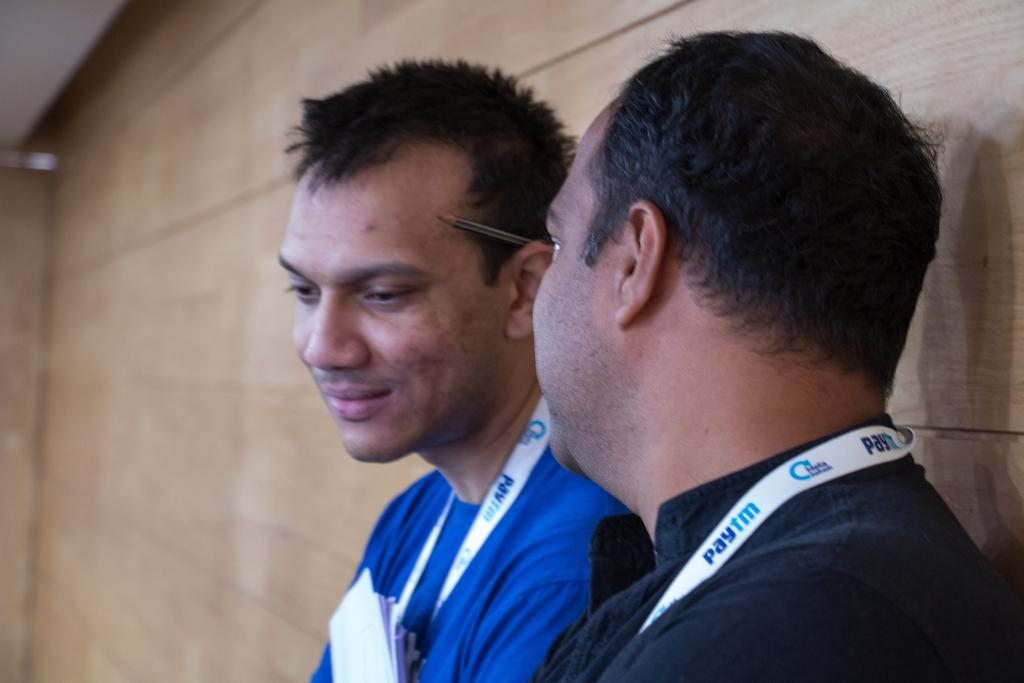<image>
Present a compact description of the photo's key features. two men sitting down chatting with badges from paytm 